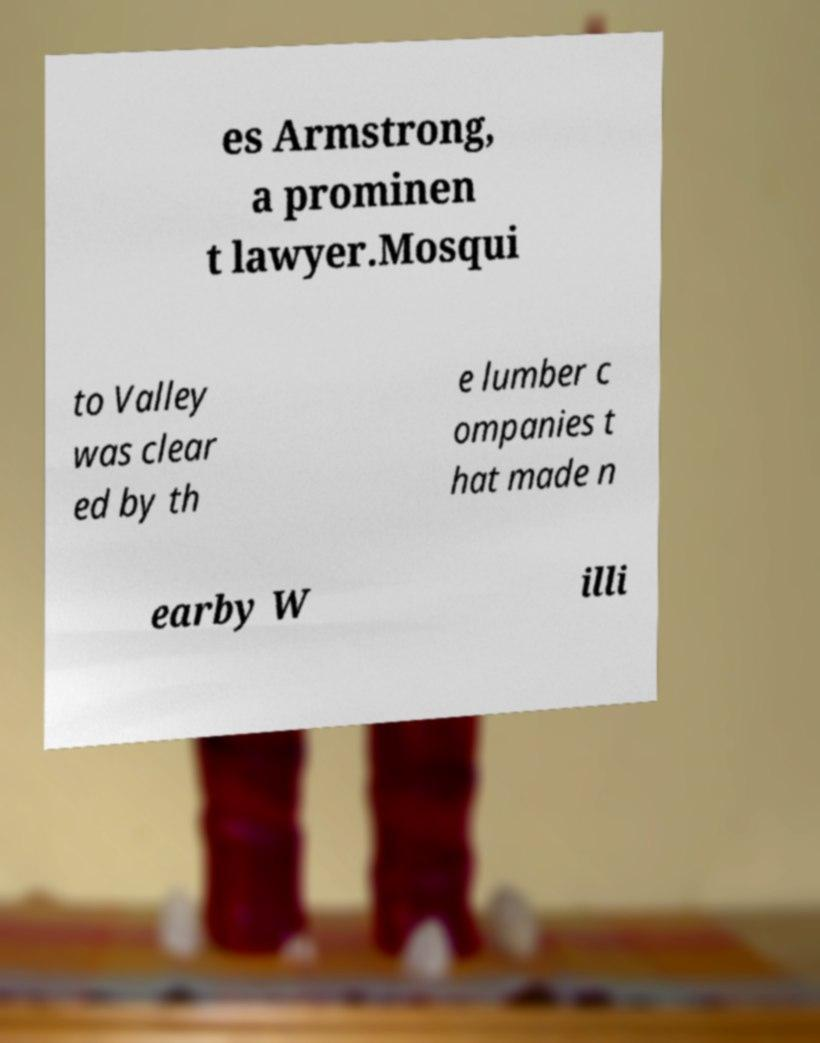Could you extract and type out the text from this image? es Armstrong, a prominen t lawyer.Mosqui to Valley was clear ed by th e lumber c ompanies t hat made n earby W illi 